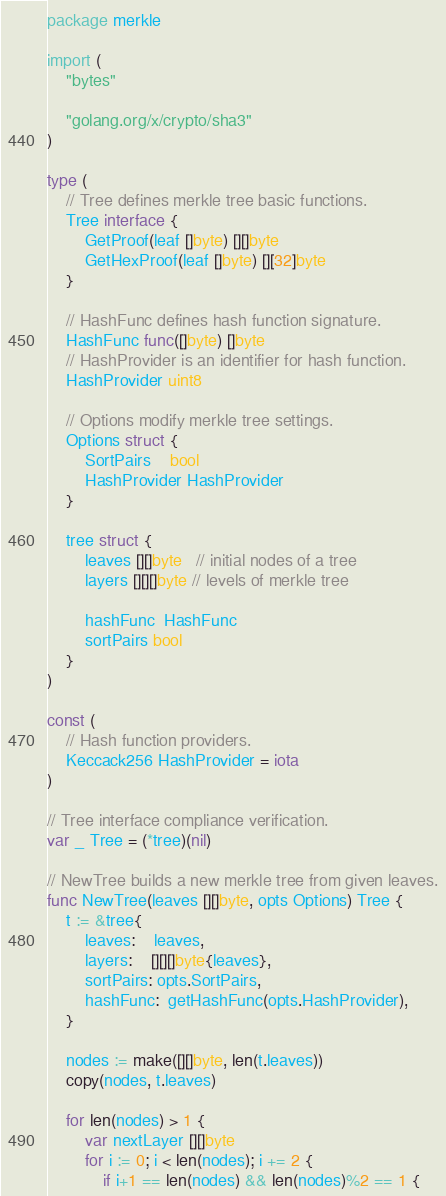<code> <loc_0><loc_0><loc_500><loc_500><_Go_>package merkle

import (
	"bytes"

	"golang.org/x/crypto/sha3"
)

type (
	// Tree defines merkle tree basic functions.
	Tree interface {
		GetProof(leaf []byte) [][]byte
		GetHexProof(leaf []byte) [][32]byte
	}

	// HashFunc defines hash function signature.
	HashFunc func([]byte) []byte
	// HashProvider is an identifier for hash function.
	HashProvider uint8

	// Options modify merkle tree settings.
	Options struct {
		SortPairs    bool
		HashProvider HashProvider
	}

	tree struct {
		leaves [][]byte   // initial nodes of a tree
		layers [][][]byte // levels of merkle tree

		hashFunc  HashFunc
		sortPairs bool
	}
)

const (
	// Hash function providers.
	Keccack256 HashProvider = iota
)

// Tree interface compliance verification.
var _ Tree = (*tree)(nil)

// NewTree builds a new merkle tree from given leaves.
func NewTree(leaves [][]byte, opts Options) Tree {
	t := &tree{
		leaves:    leaves,
		layers:    [][][]byte{leaves},
		sortPairs: opts.SortPairs,
		hashFunc:  getHashFunc(opts.HashProvider),
	}

	nodes := make([][]byte, len(t.leaves))
	copy(nodes, t.leaves)

	for len(nodes) > 1 {
		var nextLayer [][]byte
		for i := 0; i < len(nodes); i += 2 {
			if i+1 == len(nodes) && len(nodes)%2 == 1 {</code> 